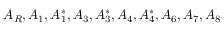<formula> <loc_0><loc_0><loc_500><loc_500>A _ { R } , A _ { 1 } , A _ { 1 } ^ { * } , A _ { 3 } , A _ { 3 } ^ { * } , A _ { 4 } , A _ { 4 } ^ { * } , A _ { 6 } , A _ { 7 } , A _ { 8 }</formula> 